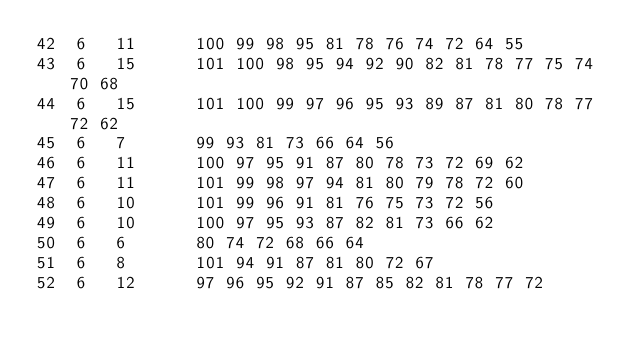Convert code to text. <code><loc_0><loc_0><loc_500><loc_500><_ObjectiveC_>42	6	11		100 99 98 95 81 78 76 74 72 64 55 
43	6	15		101 100 98 95 94 92 90 82 81 78 77 75 74 70 68 
44	6	15		101 100 99 97 96 95 93 89 87 81 80 78 77 72 62 
45	6	7		99 93 81 73 66 64 56 
46	6	11		100 97 95 91 87 80 78 73 72 69 62 
47	6	11		101 99 98 97 94 81 80 79 78 72 60 
48	6	10		101 99 96 91 81 76 75 73 72 56 
49	6	10		100 97 95 93 87 82 81 73 66 62 
50	6	6		80 74 72 68 66 64 
51	6	8		101 94 91 87 81 80 72 67 
52	6	12		97 96 95 92 91 87 85 82 81 78 77 72 </code> 